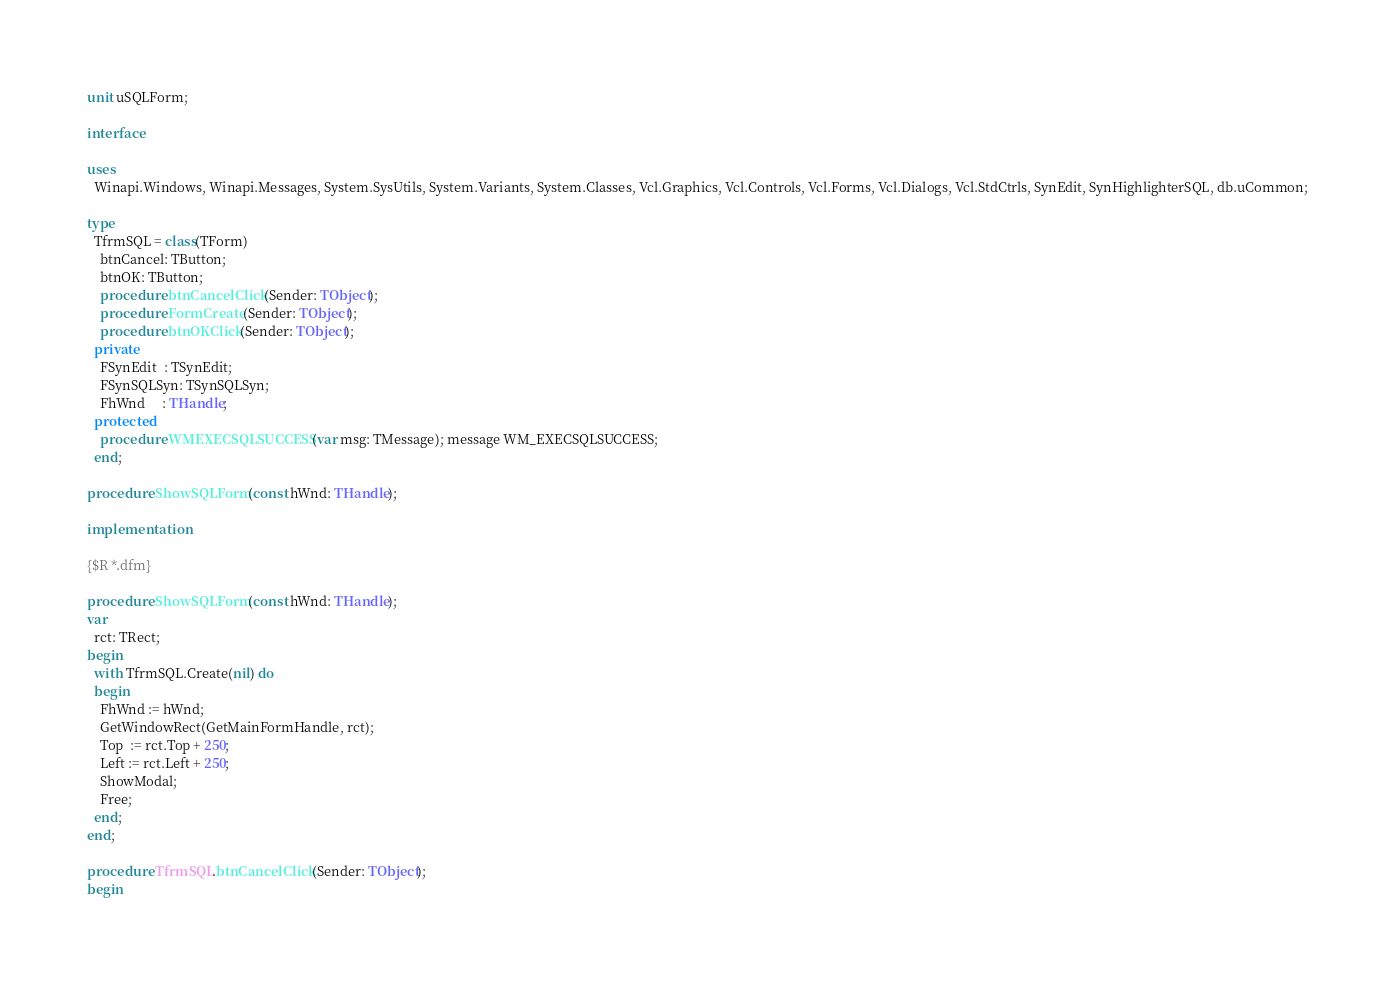<code> <loc_0><loc_0><loc_500><loc_500><_Pascal_>unit uSQLForm;

interface

uses
  Winapi.Windows, Winapi.Messages, System.SysUtils, System.Variants, System.Classes, Vcl.Graphics, Vcl.Controls, Vcl.Forms, Vcl.Dialogs, Vcl.StdCtrls, SynEdit, SynHighlighterSQL, db.uCommon;

type
  TfrmSQL = class(TForm)
    btnCancel: TButton;
    btnOK: TButton;
    procedure btnCancelClick(Sender: TObject);
    procedure FormCreate(Sender: TObject);
    procedure btnOKClick(Sender: TObject);
  private
    FSynEdit  : TSynEdit;
    FSynSQLSyn: TSynSQLSyn;
    FhWnd     : THandle;
  protected
    procedure WMEXECSQLSUCCESS(var msg: TMessage); message WM_EXECSQLSUCCESS;
  end;

procedure ShowSQLForm(const hWnd: THandle);

implementation

{$R *.dfm}

procedure ShowSQLForm(const hWnd: THandle);
var
  rct: TRect;
begin
  with TfrmSQL.Create(nil) do
  begin
    FhWnd := hWnd;
    GetWindowRect(GetMainFormHandle, rct);
    Top  := rct.Top + 250;
    Left := rct.Left + 250;
    ShowModal;
    Free;
  end;
end;

procedure TfrmSQL.btnCancelClick(Sender: TObject);
begin</code> 